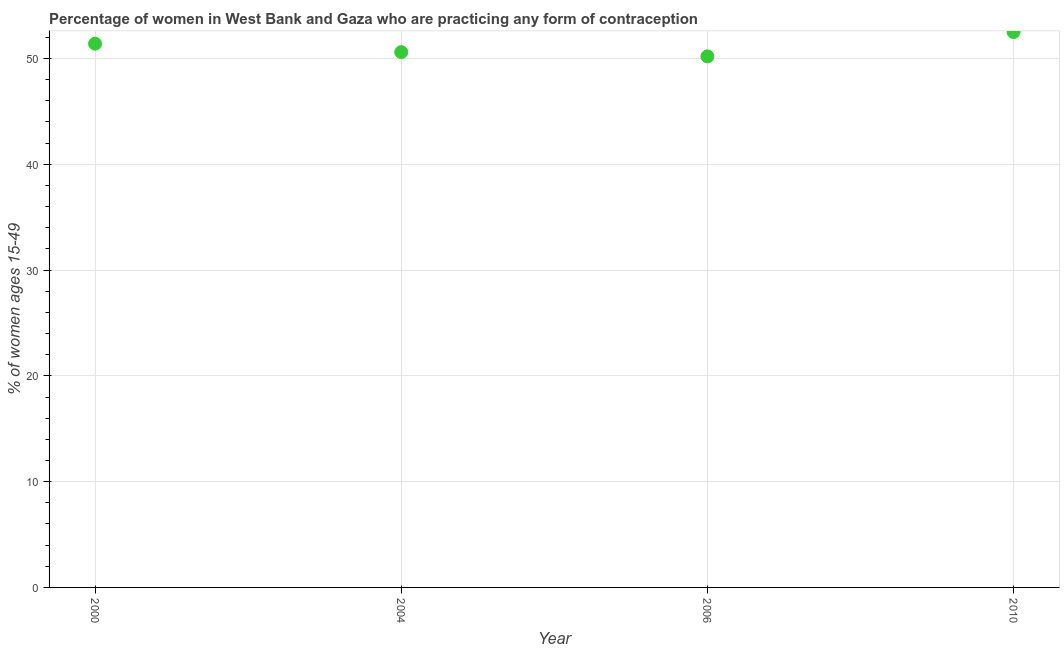What is the contraceptive prevalence in 2010?
Ensure brevity in your answer.  52.5. Across all years, what is the maximum contraceptive prevalence?
Your answer should be very brief. 52.5. Across all years, what is the minimum contraceptive prevalence?
Give a very brief answer. 50.2. In which year was the contraceptive prevalence maximum?
Your answer should be compact. 2010. In which year was the contraceptive prevalence minimum?
Keep it short and to the point. 2006. What is the sum of the contraceptive prevalence?
Your response must be concise. 204.7. What is the difference between the contraceptive prevalence in 2000 and 2004?
Provide a succinct answer. 0.8. What is the average contraceptive prevalence per year?
Ensure brevity in your answer.  51.17. In how many years, is the contraceptive prevalence greater than 12 %?
Give a very brief answer. 4. What is the ratio of the contraceptive prevalence in 2000 to that in 2006?
Your answer should be very brief. 1.02. Is the contraceptive prevalence in 2004 less than that in 2010?
Provide a succinct answer. Yes. Is the difference between the contraceptive prevalence in 2006 and 2010 greater than the difference between any two years?
Your answer should be very brief. Yes. What is the difference between the highest and the second highest contraceptive prevalence?
Provide a short and direct response. 1.1. What is the difference between the highest and the lowest contraceptive prevalence?
Offer a very short reply. 2.3. In how many years, is the contraceptive prevalence greater than the average contraceptive prevalence taken over all years?
Provide a succinct answer. 2. Does the contraceptive prevalence monotonically increase over the years?
Offer a terse response. No. How many dotlines are there?
Your answer should be very brief. 1. How many years are there in the graph?
Provide a succinct answer. 4. Are the values on the major ticks of Y-axis written in scientific E-notation?
Keep it short and to the point. No. Does the graph contain grids?
Make the answer very short. Yes. What is the title of the graph?
Offer a terse response. Percentage of women in West Bank and Gaza who are practicing any form of contraception. What is the label or title of the Y-axis?
Keep it short and to the point. % of women ages 15-49. What is the % of women ages 15-49 in 2000?
Make the answer very short. 51.4. What is the % of women ages 15-49 in 2004?
Your response must be concise. 50.6. What is the % of women ages 15-49 in 2006?
Give a very brief answer. 50.2. What is the % of women ages 15-49 in 2010?
Make the answer very short. 52.5. What is the difference between the % of women ages 15-49 in 2000 and 2006?
Your answer should be very brief. 1.2. What is the difference between the % of women ages 15-49 in 2006 and 2010?
Provide a succinct answer. -2.3. What is the ratio of the % of women ages 15-49 in 2000 to that in 2004?
Make the answer very short. 1.02. What is the ratio of the % of women ages 15-49 in 2000 to that in 2010?
Your answer should be compact. 0.98. What is the ratio of the % of women ages 15-49 in 2006 to that in 2010?
Keep it short and to the point. 0.96. 